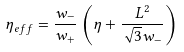Convert formula to latex. <formula><loc_0><loc_0><loc_500><loc_500>\eta _ { e f f } = \frac { w _ { - } } { w _ { + } } \left ( \eta + \frac { L ^ { 2 } } { \sqrt { 3 } w _ { - } } \right )</formula> 